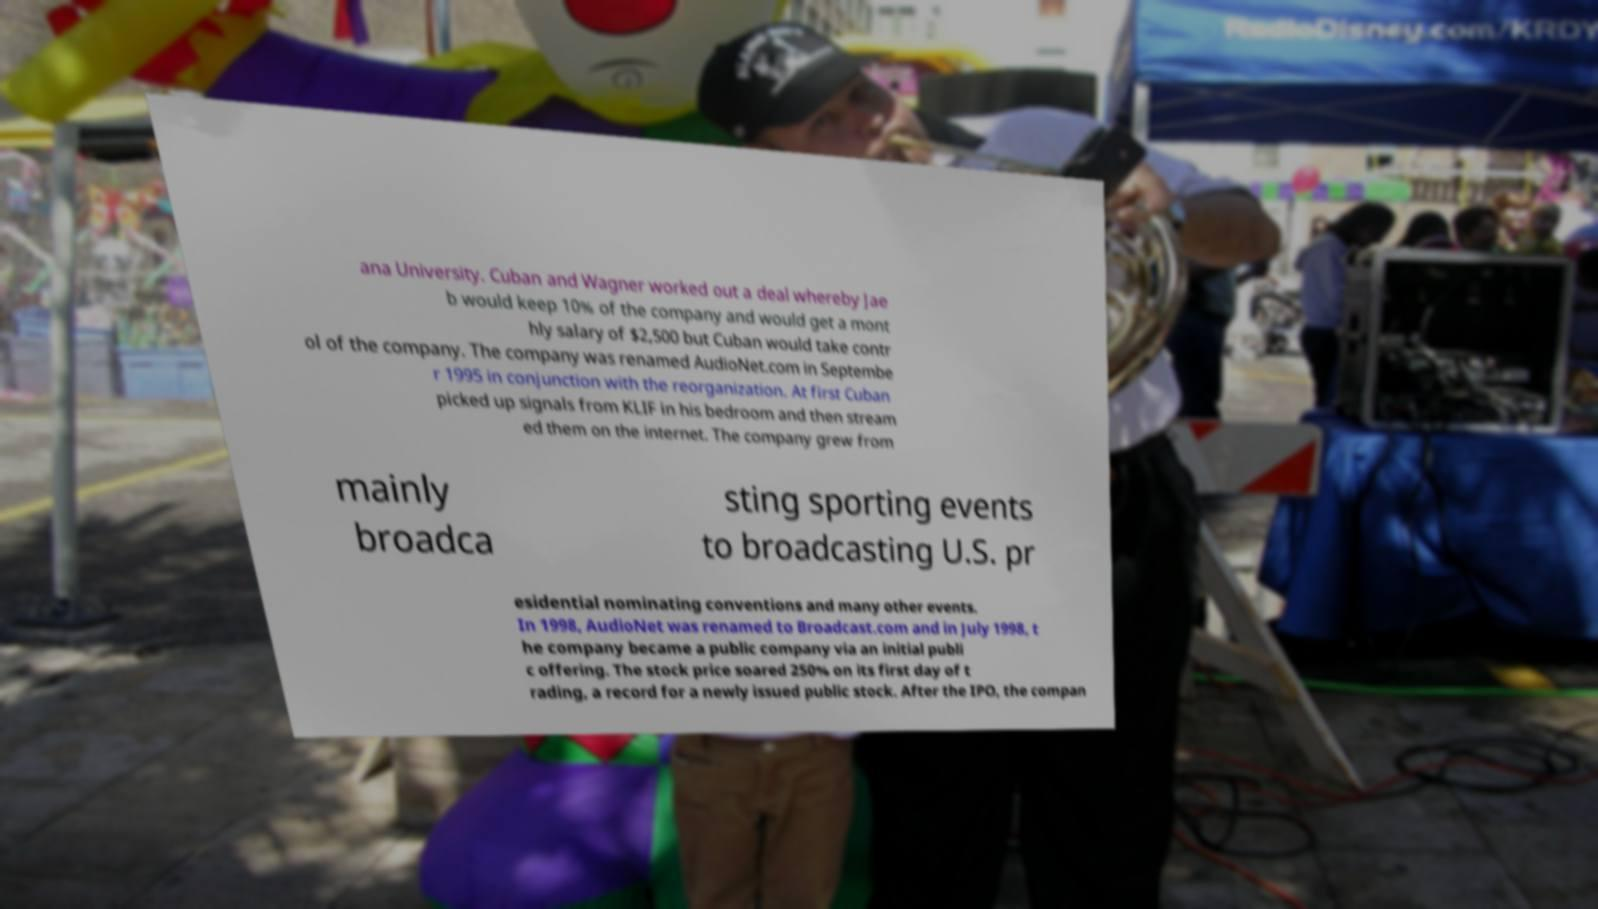I need the written content from this picture converted into text. Can you do that? ana University. Cuban and Wagner worked out a deal whereby Jae b would keep 10% of the company and would get a mont hly salary of $2,500 but Cuban would take contr ol of the company. The company was renamed AudioNet.com in Septembe r 1995 in conjunction with the reorganization. At first Cuban picked up signals from KLIF in his bedroom and then stream ed them on the internet. The company grew from mainly broadca sting sporting events to broadcasting U.S. pr esidential nominating conventions and many other events. In 1998, AudioNet was renamed to Broadcast.com and in July 1998, t he company became a public company via an initial publi c offering. The stock price soared 250% on its first day of t rading, a record for a newly issued public stock. After the IPO, the compan 